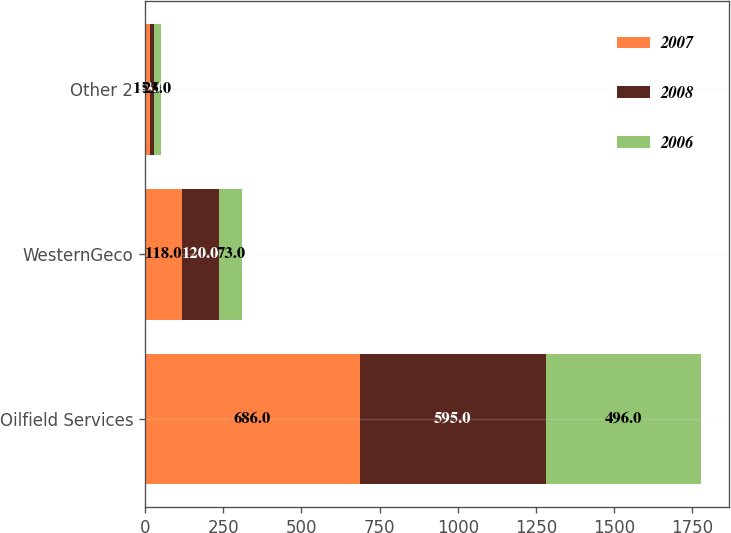Convert chart to OTSL. <chart><loc_0><loc_0><loc_500><loc_500><stacked_bar_chart><ecel><fcel>Oilfield Services<fcel>WesternGeco<fcel>Other 2<nl><fcel>2007<fcel>686<fcel>118<fcel>15<nl><fcel>2008<fcel>595<fcel>120<fcel>13<nl><fcel>2006<fcel>496<fcel>73<fcel>23<nl></chart> 